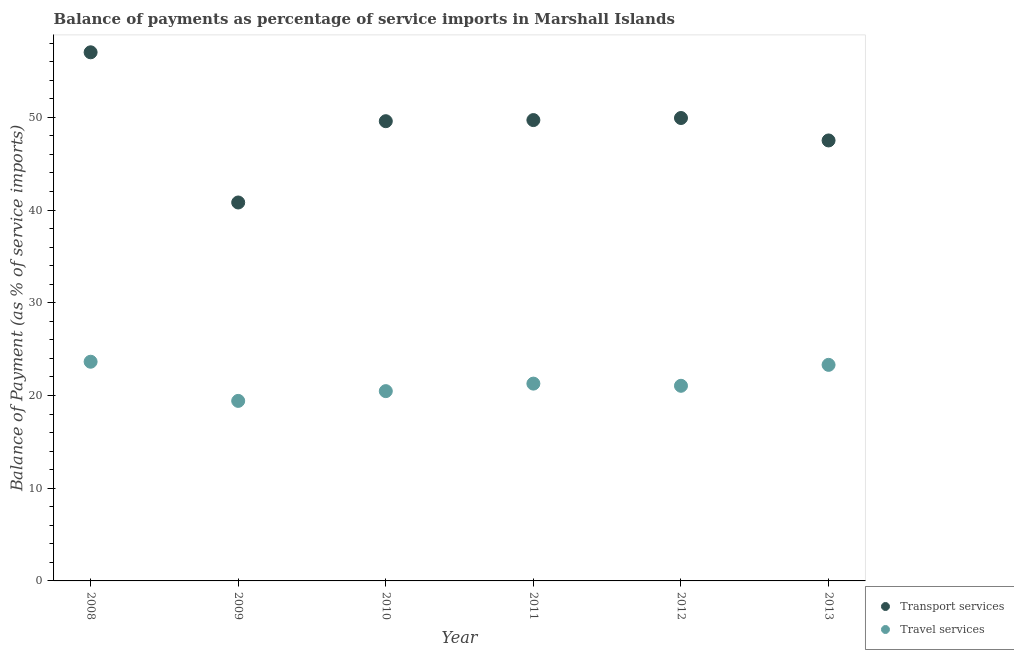How many different coloured dotlines are there?
Ensure brevity in your answer.  2. Is the number of dotlines equal to the number of legend labels?
Provide a short and direct response. Yes. What is the balance of payments of travel services in 2011?
Your response must be concise. 21.28. Across all years, what is the maximum balance of payments of transport services?
Offer a very short reply. 57.01. Across all years, what is the minimum balance of payments of transport services?
Provide a succinct answer. 40.81. In which year was the balance of payments of transport services minimum?
Give a very brief answer. 2009. What is the total balance of payments of transport services in the graph?
Make the answer very short. 294.53. What is the difference between the balance of payments of transport services in 2008 and that in 2012?
Provide a short and direct response. 7.09. What is the difference between the balance of payments of transport services in 2011 and the balance of payments of travel services in 2010?
Ensure brevity in your answer.  29.23. What is the average balance of payments of transport services per year?
Offer a very short reply. 49.09. In the year 2010, what is the difference between the balance of payments of travel services and balance of payments of transport services?
Offer a very short reply. -29.11. In how many years, is the balance of payments of travel services greater than 54 %?
Provide a succinct answer. 0. What is the ratio of the balance of payments of travel services in 2008 to that in 2012?
Provide a succinct answer. 1.12. What is the difference between the highest and the second highest balance of payments of transport services?
Your answer should be very brief. 7.09. What is the difference between the highest and the lowest balance of payments of travel services?
Your answer should be very brief. 4.22. Is the balance of payments of transport services strictly less than the balance of payments of travel services over the years?
Your answer should be very brief. No. How many dotlines are there?
Keep it short and to the point. 2. Are the values on the major ticks of Y-axis written in scientific E-notation?
Provide a short and direct response. No. Does the graph contain any zero values?
Provide a short and direct response. No. Where does the legend appear in the graph?
Offer a terse response. Bottom right. How many legend labels are there?
Offer a terse response. 2. How are the legend labels stacked?
Make the answer very short. Vertical. What is the title of the graph?
Offer a terse response. Balance of payments as percentage of service imports in Marshall Islands. What is the label or title of the X-axis?
Offer a terse response. Year. What is the label or title of the Y-axis?
Your answer should be compact. Balance of Payment (as % of service imports). What is the Balance of Payment (as % of service imports) in Transport services in 2008?
Your answer should be very brief. 57.01. What is the Balance of Payment (as % of service imports) in Travel services in 2008?
Provide a short and direct response. 23.64. What is the Balance of Payment (as % of service imports) in Transport services in 2009?
Provide a short and direct response. 40.81. What is the Balance of Payment (as % of service imports) of Travel services in 2009?
Ensure brevity in your answer.  19.42. What is the Balance of Payment (as % of service imports) of Transport services in 2010?
Ensure brevity in your answer.  49.58. What is the Balance of Payment (as % of service imports) of Travel services in 2010?
Your answer should be very brief. 20.47. What is the Balance of Payment (as % of service imports) of Transport services in 2011?
Offer a terse response. 49.7. What is the Balance of Payment (as % of service imports) of Travel services in 2011?
Your response must be concise. 21.28. What is the Balance of Payment (as % of service imports) of Transport services in 2012?
Offer a very short reply. 49.92. What is the Balance of Payment (as % of service imports) of Travel services in 2012?
Offer a terse response. 21.04. What is the Balance of Payment (as % of service imports) of Transport services in 2013?
Your answer should be compact. 47.5. What is the Balance of Payment (as % of service imports) in Travel services in 2013?
Provide a short and direct response. 23.3. Across all years, what is the maximum Balance of Payment (as % of service imports) of Transport services?
Offer a terse response. 57.01. Across all years, what is the maximum Balance of Payment (as % of service imports) of Travel services?
Provide a short and direct response. 23.64. Across all years, what is the minimum Balance of Payment (as % of service imports) in Transport services?
Offer a terse response. 40.81. Across all years, what is the minimum Balance of Payment (as % of service imports) of Travel services?
Your answer should be very brief. 19.42. What is the total Balance of Payment (as % of service imports) of Transport services in the graph?
Make the answer very short. 294.53. What is the total Balance of Payment (as % of service imports) in Travel services in the graph?
Your answer should be compact. 129.15. What is the difference between the Balance of Payment (as % of service imports) in Transport services in 2008 and that in 2009?
Offer a very short reply. 16.2. What is the difference between the Balance of Payment (as % of service imports) of Travel services in 2008 and that in 2009?
Your answer should be very brief. 4.22. What is the difference between the Balance of Payment (as % of service imports) of Transport services in 2008 and that in 2010?
Your answer should be compact. 7.43. What is the difference between the Balance of Payment (as % of service imports) of Travel services in 2008 and that in 2010?
Ensure brevity in your answer.  3.17. What is the difference between the Balance of Payment (as % of service imports) of Transport services in 2008 and that in 2011?
Keep it short and to the point. 7.31. What is the difference between the Balance of Payment (as % of service imports) of Travel services in 2008 and that in 2011?
Your response must be concise. 2.36. What is the difference between the Balance of Payment (as % of service imports) of Transport services in 2008 and that in 2012?
Your answer should be compact. 7.09. What is the difference between the Balance of Payment (as % of service imports) of Travel services in 2008 and that in 2012?
Your response must be concise. 2.59. What is the difference between the Balance of Payment (as % of service imports) in Transport services in 2008 and that in 2013?
Make the answer very short. 9.51. What is the difference between the Balance of Payment (as % of service imports) of Travel services in 2008 and that in 2013?
Your response must be concise. 0.34. What is the difference between the Balance of Payment (as % of service imports) in Transport services in 2009 and that in 2010?
Provide a short and direct response. -8.77. What is the difference between the Balance of Payment (as % of service imports) in Travel services in 2009 and that in 2010?
Offer a very short reply. -1.05. What is the difference between the Balance of Payment (as % of service imports) in Transport services in 2009 and that in 2011?
Your answer should be very brief. -8.89. What is the difference between the Balance of Payment (as % of service imports) of Travel services in 2009 and that in 2011?
Ensure brevity in your answer.  -1.86. What is the difference between the Balance of Payment (as % of service imports) in Transport services in 2009 and that in 2012?
Ensure brevity in your answer.  -9.11. What is the difference between the Balance of Payment (as % of service imports) in Travel services in 2009 and that in 2012?
Make the answer very short. -1.63. What is the difference between the Balance of Payment (as % of service imports) of Transport services in 2009 and that in 2013?
Provide a short and direct response. -6.69. What is the difference between the Balance of Payment (as % of service imports) of Travel services in 2009 and that in 2013?
Your response must be concise. -3.89. What is the difference between the Balance of Payment (as % of service imports) in Transport services in 2010 and that in 2011?
Give a very brief answer. -0.12. What is the difference between the Balance of Payment (as % of service imports) in Travel services in 2010 and that in 2011?
Your response must be concise. -0.81. What is the difference between the Balance of Payment (as % of service imports) in Transport services in 2010 and that in 2012?
Keep it short and to the point. -0.34. What is the difference between the Balance of Payment (as % of service imports) of Travel services in 2010 and that in 2012?
Offer a terse response. -0.58. What is the difference between the Balance of Payment (as % of service imports) in Transport services in 2010 and that in 2013?
Give a very brief answer. 2.08. What is the difference between the Balance of Payment (as % of service imports) of Travel services in 2010 and that in 2013?
Make the answer very short. -2.83. What is the difference between the Balance of Payment (as % of service imports) in Transport services in 2011 and that in 2012?
Offer a terse response. -0.22. What is the difference between the Balance of Payment (as % of service imports) in Travel services in 2011 and that in 2012?
Keep it short and to the point. 0.23. What is the difference between the Balance of Payment (as % of service imports) in Transport services in 2011 and that in 2013?
Ensure brevity in your answer.  2.2. What is the difference between the Balance of Payment (as % of service imports) in Travel services in 2011 and that in 2013?
Make the answer very short. -2.02. What is the difference between the Balance of Payment (as % of service imports) of Transport services in 2012 and that in 2013?
Offer a terse response. 2.42. What is the difference between the Balance of Payment (as % of service imports) of Travel services in 2012 and that in 2013?
Your answer should be compact. -2.26. What is the difference between the Balance of Payment (as % of service imports) of Transport services in 2008 and the Balance of Payment (as % of service imports) of Travel services in 2009?
Your answer should be compact. 37.59. What is the difference between the Balance of Payment (as % of service imports) of Transport services in 2008 and the Balance of Payment (as % of service imports) of Travel services in 2010?
Keep it short and to the point. 36.54. What is the difference between the Balance of Payment (as % of service imports) of Transport services in 2008 and the Balance of Payment (as % of service imports) of Travel services in 2011?
Give a very brief answer. 35.73. What is the difference between the Balance of Payment (as % of service imports) of Transport services in 2008 and the Balance of Payment (as % of service imports) of Travel services in 2012?
Your answer should be very brief. 35.97. What is the difference between the Balance of Payment (as % of service imports) in Transport services in 2008 and the Balance of Payment (as % of service imports) in Travel services in 2013?
Keep it short and to the point. 33.71. What is the difference between the Balance of Payment (as % of service imports) in Transport services in 2009 and the Balance of Payment (as % of service imports) in Travel services in 2010?
Ensure brevity in your answer.  20.34. What is the difference between the Balance of Payment (as % of service imports) in Transport services in 2009 and the Balance of Payment (as % of service imports) in Travel services in 2011?
Your answer should be very brief. 19.53. What is the difference between the Balance of Payment (as % of service imports) in Transport services in 2009 and the Balance of Payment (as % of service imports) in Travel services in 2012?
Provide a short and direct response. 19.77. What is the difference between the Balance of Payment (as % of service imports) in Transport services in 2009 and the Balance of Payment (as % of service imports) in Travel services in 2013?
Your response must be concise. 17.51. What is the difference between the Balance of Payment (as % of service imports) of Transport services in 2010 and the Balance of Payment (as % of service imports) of Travel services in 2011?
Provide a succinct answer. 28.3. What is the difference between the Balance of Payment (as % of service imports) of Transport services in 2010 and the Balance of Payment (as % of service imports) of Travel services in 2012?
Your answer should be very brief. 28.54. What is the difference between the Balance of Payment (as % of service imports) in Transport services in 2010 and the Balance of Payment (as % of service imports) in Travel services in 2013?
Give a very brief answer. 26.28. What is the difference between the Balance of Payment (as % of service imports) in Transport services in 2011 and the Balance of Payment (as % of service imports) in Travel services in 2012?
Offer a very short reply. 28.66. What is the difference between the Balance of Payment (as % of service imports) in Transport services in 2011 and the Balance of Payment (as % of service imports) in Travel services in 2013?
Your answer should be very brief. 26.4. What is the difference between the Balance of Payment (as % of service imports) in Transport services in 2012 and the Balance of Payment (as % of service imports) in Travel services in 2013?
Offer a terse response. 26.62. What is the average Balance of Payment (as % of service imports) of Transport services per year?
Give a very brief answer. 49.09. What is the average Balance of Payment (as % of service imports) of Travel services per year?
Your response must be concise. 21.52. In the year 2008, what is the difference between the Balance of Payment (as % of service imports) in Transport services and Balance of Payment (as % of service imports) in Travel services?
Offer a terse response. 33.37. In the year 2009, what is the difference between the Balance of Payment (as % of service imports) of Transport services and Balance of Payment (as % of service imports) of Travel services?
Make the answer very short. 21.4. In the year 2010, what is the difference between the Balance of Payment (as % of service imports) of Transport services and Balance of Payment (as % of service imports) of Travel services?
Your response must be concise. 29.11. In the year 2011, what is the difference between the Balance of Payment (as % of service imports) in Transport services and Balance of Payment (as % of service imports) in Travel services?
Offer a terse response. 28.42. In the year 2012, what is the difference between the Balance of Payment (as % of service imports) in Transport services and Balance of Payment (as % of service imports) in Travel services?
Your response must be concise. 28.88. In the year 2013, what is the difference between the Balance of Payment (as % of service imports) of Transport services and Balance of Payment (as % of service imports) of Travel services?
Your response must be concise. 24.2. What is the ratio of the Balance of Payment (as % of service imports) in Transport services in 2008 to that in 2009?
Offer a terse response. 1.4. What is the ratio of the Balance of Payment (as % of service imports) of Travel services in 2008 to that in 2009?
Your answer should be very brief. 1.22. What is the ratio of the Balance of Payment (as % of service imports) of Transport services in 2008 to that in 2010?
Keep it short and to the point. 1.15. What is the ratio of the Balance of Payment (as % of service imports) of Travel services in 2008 to that in 2010?
Keep it short and to the point. 1.15. What is the ratio of the Balance of Payment (as % of service imports) in Transport services in 2008 to that in 2011?
Provide a succinct answer. 1.15. What is the ratio of the Balance of Payment (as % of service imports) of Travel services in 2008 to that in 2011?
Offer a terse response. 1.11. What is the ratio of the Balance of Payment (as % of service imports) in Transport services in 2008 to that in 2012?
Provide a short and direct response. 1.14. What is the ratio of the Balance of Payment (as % of service imports) of Travel services in 2008 to that in 2012?
Your answer should be very brief. 1.12. What is the ratio of the Balance of Payment (as % of service imports) in Transport services in 2008 to that in 2013?
Provide a short and direct response. 1.2. What is the ratio of the Balance of Payment (as % of service imports) of Travel services in 2008 to that in 2013?
Keep it short and to the point. 1.01. What is the ratio of the Balance of Payment (as % of service imports) in Transport services in 2009 to that in 2010?
Your answer should be very brief. 0.82. What is the ratio of the Balance of Payment (as % of service imports) of Travel services in 2009 to that in 2010?
Provide a short and direct response. 0.95. What is the ratio of the Balance of Payment (as % of service imports) in Transport services in 2009 to that in 2011?
Your response must be concise. 0.82. What is the ratio of the Balance of Payment (as % of service imports) of Travel services in 2009 to that in 2011?
Provide a short and direct response. 0.91. What is the ratio of the Balance of Payment (as % of service imports) of Transport services in 2009 to that in 2012?
Offer a very short reply. 0.82. What is the ratio of the Balance of Payment (as % of service imports) in Travel services in 2009 to that in 2012?
Your response must be concise. 0.92. What is the ratio of the Balance of Payment (as % of service imports) of Transport services in 2009 to that in 2013?
Offer a terse response. 0.86. What is the ratio of the Balance of Payment (as % of service imports) in Travel services in 2009 to that in 2013?
Keep it short and to the point. 0.83. What is the ratio of the Balance of Payment (as % of service imports) in Transport services in 2010 to that in 2011?
Your answer should be compact. 1. What is the ratio of the Balance of Payment (as % of service imports) in Travel services in 2010 to that in 2011?
Your response must be concise. 0.96. What is the ratio of the Balance of Payment (as % of service imports) of Travel services in 2010 to that in 2012?
Give a very brief answer. 0.97. What is the ratio of the Balance of Payment (as % of service imports) of Transport services in 2010 to that in 2013?
Provide a short and direct response. 1.04. What is the ratio of the Balance of Payment (as % of service imports) in Travel services in 2010 to that in 2013?
Offer a terse response. 0.88. What is the ratio of the Balance of Payment (as % of service imports) of Transport services in 2011 to that in 2012?
Ensure brevity in your answer.  1. What is the ratio of the Balance of Payment (as % of service imports) in Travel services in 2011 to that in 2012?
Keep it short and to the point. 1.01. What is the ratio of the Balance of Payment (as % of service imports) of Transport services in 2011 to that in 2013?
Offer a very short reply. 1.05. What is the ratio of the Balance of Payment (as % of service imports) in Travel services in 2011 to that in 2013?
Provide a short and direct response. 0.91. What is the ratio of the Balance of Payment (as % of service imports) in Transport services in 2012 to that in 2013?
Your response must be concise. 1.05. What is the ratio of the Balance of Payment (as % of service imports) in Travel services in 2012 to that in 2013?
Give a very brief answer. 0.9. What is the difference between the highest and the second highest Balance of Payment (as % of service imports) in Transport services?
Your answer should be compact. 7.09. What is the difference between the highest and the second highest Balance of Payment (as % of service imports) in Travel services?
Offer a very short reply. 0.34. What is the difference between the highest and the lowest Balance of Payment (as % of service imports) of Transport services?
Your answer should be very brief. 16.2. What is the difference between the highest and the lowest Balance of Payment (as % of service imports) of Travel services?
Keep it short and to the point. 4.22. 